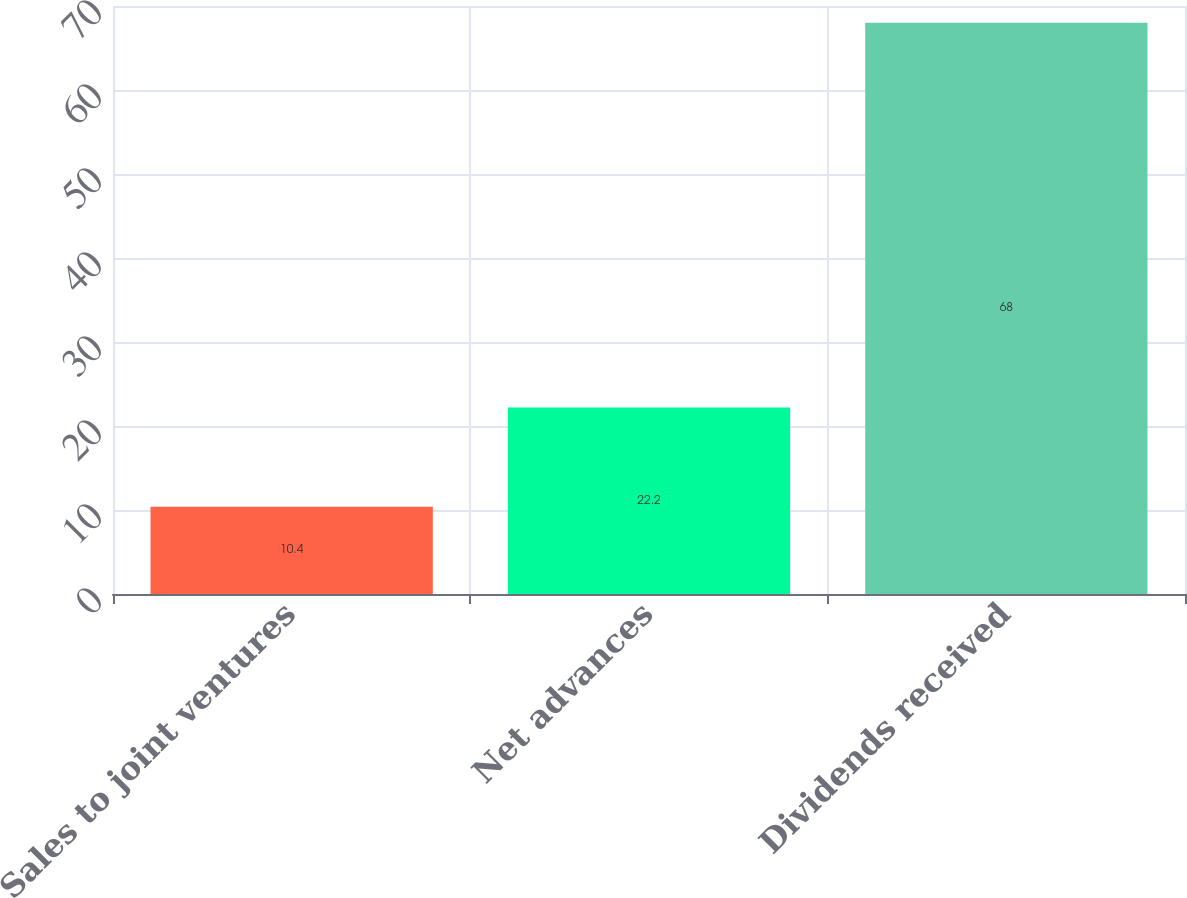<chart> <loc_0><loc_0><loc_500><loc_500><bar_chart><fcel>Sales to joint ventures<fcel>Net advances<fcel>Dividends received<nl><fcel>10.4<fcel>22.2<fcel>68<nl></chart> 